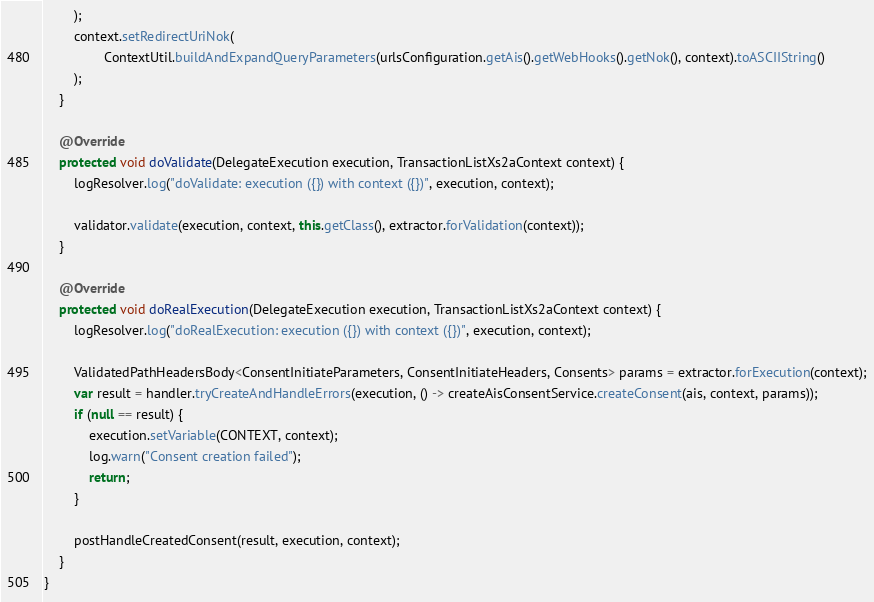<code> <loc_0><loc_0><loc_500><loc_500><_Java_>        );
        context.setRedirectUriNok(
                ContextUtil.buildAndExpandQueryParameters(urlsConfiguration.getAis().getWebHooks().getNok(), context).toASCIIString()
        );
    }

    @Override
    protected void doValidate(DelegateExecution execution, TransactionListXs2aContext context) {
        logResolver.log("doValidate: execution ({}) with context ({})", execution, context);

        validator.validate(execution, context, this.getClass(), extractor.forValidation(context));
    }

    @Override
    protected void doRealExecution(DelegateExecution execution, TransactionListXs2aContext context) {
        logResolver.log("doRealExecution: execution ({}) with context ({})", execution, context);

        ValidatedPathHeadersBody<ConsentInitiateParameters, ConsentInitiateHeaders, Consents> params = extractor.forExecution(context);
        var result = handler.tryCreateAndHandleErrors(execution, () -> createAisConsentService.createConsent(ais, context, params));
        if (null == result) {
            execution.setVariable(CONTEXT, context);
            log.warn("Consent creation failed");
            return;
        }

        postHandleCreatedConsent(result, execution, context);
    }
}
</code> 